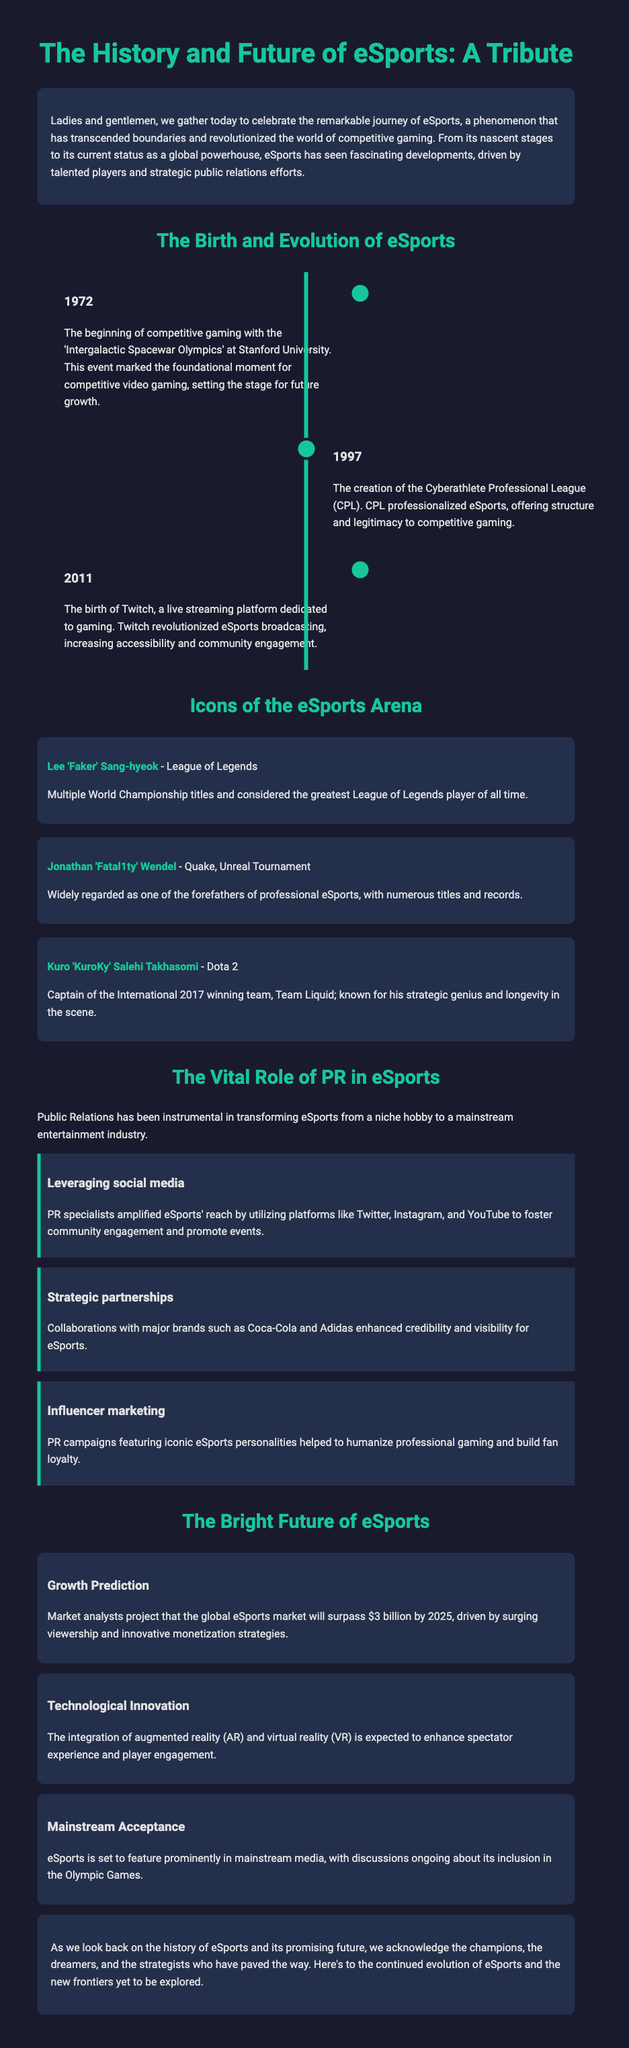What year did the 'Intergalactic Spacewar Olympics' take place? The document mentions that this event occurred in 1972, marking the beginning of competitive gaming.
Answer: 1972 Who is considered the greatest League of Legends player of all time? According to the document, Lee 'Faker' Sang-hyeok is recognized for this title, having multiple World Championship wins.
Answer: Lee 'Faker' Sang-hyeok In what year was Twitch launched? The document states that Twitch was founded in 2011, revolutionizing eSports broadcasting.
Answer: 2011 What is projected to surpass $3 billion by 2025? Market analysts expect the global eSports market to exceed this value due to growing viewership and monetization.
Answer: $3 billion Which brand collaborated with eSports to enhance credibility? The document lists Coca-Cola as one of the major brands that partnered with eSports, boosting its visibility.
Answer: Coca-Cola What type of marketing involved iconic eSports personalities? Influencer marketing is described in the document as a strategy that helped build fan loyalty and humanize professional gaming.
Answer: Influencer marketing What is one technological innovation expected to enhance eSports? The document mentions augmented reality (AR) and virtual reality (VR) as technologies that will improve spectator experience.
Answer: Augmented reality (AR) and virtual reality (VR) What was one of the vital roles of PR in the evolution of eSports? The document highlights the use of social media by PR specialists to engage the community and promote events.
Answer: Leveraging social media Who captained Team Liquid to victory in the International 2017? Kuro 'KuroKy' Salehi Takhasomi is recognized in the document as the captain of the winning team in that tournament.
Answer: Kuro 'KuroKy' Salehi Takhasomi 